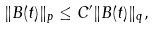<formula> <loc_0><loc_0><loc_500><loc_500>\| B ( t ) \| _ { p } \leq C ^ { \prime } \| B ( t ) \| _ { q } ,</formula> 